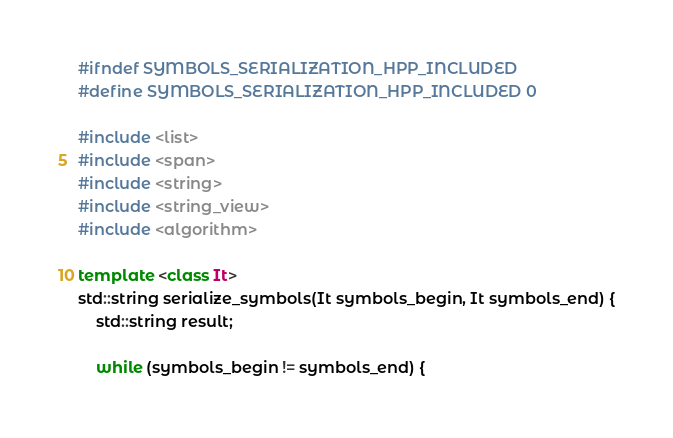Convert code to text. <code><loc_0><loc_0><loc_500><loc_500><_C++_>#ifndef SYMBOLS_SERIALIZATION_HPP_INCLUDED
#define SYMBOLS_SERIALIZATION_HPP_INCLUDED 0

#include <list>
#include <span>
#include <string>
#include <string_view>
#include <algorithm>

template <class It>
std::string serialize_symbols(It symbols_begin, It symbols_end) {
    std::string result;

    while (symbols_begin != symbols_end) {</code> 